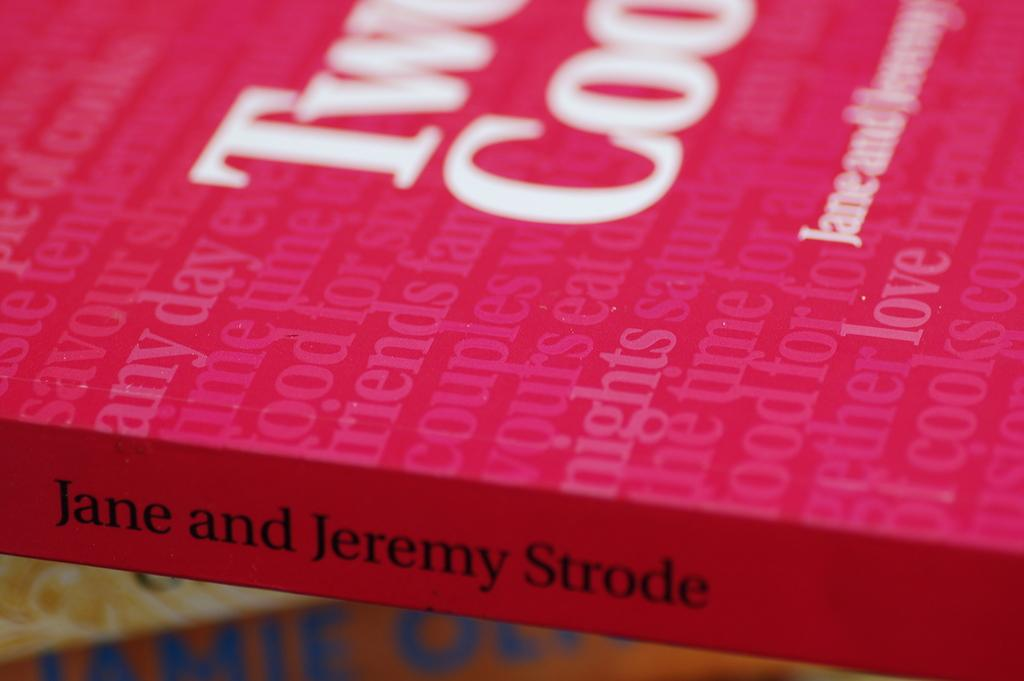<image>
Share a concise interpretation of the image provided. The spine of a book written by Jane and Jeremy Strode. 